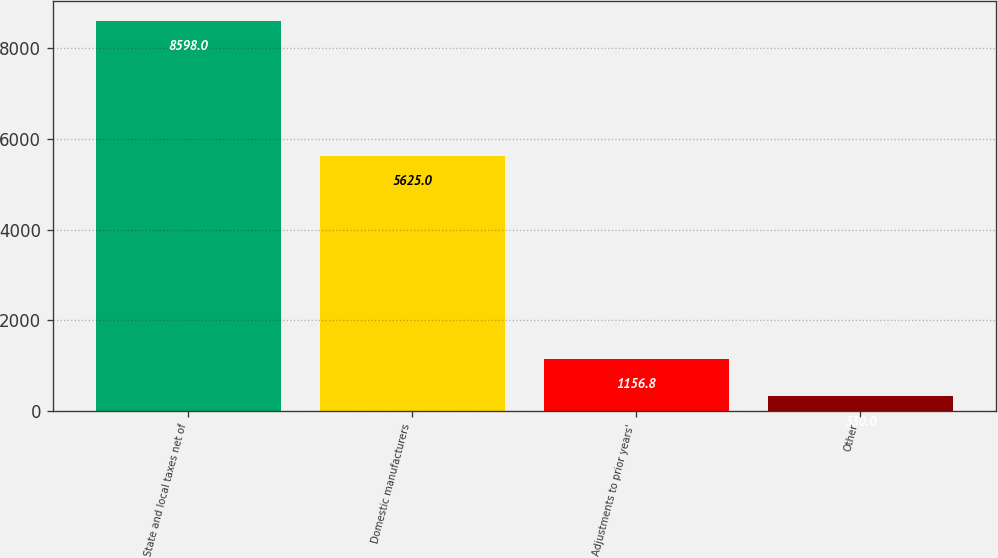<chart> <loc_0><loc_0><loc_500><loc_500><bar_chart><fcel>State and local taxes net of<fcel>Domestic manufacturers<fcel>Adjustments to prior years'<fcel>Other<nl><fcel>8598<fcel>5625<fcel>1156.8<fcel>330<nl></chart> 